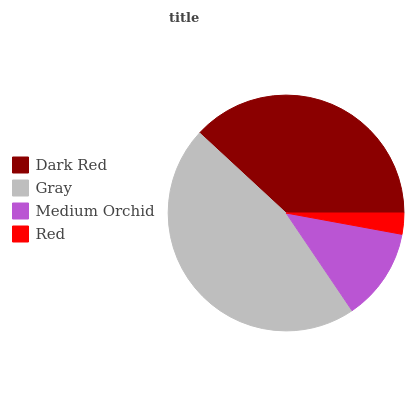Is Red the minimum?
Answer yes or no. Yes. Is Gray the maximum?
Answer yes or no. Yes. Is Medium Orchid the minimum?
Answer yes or no. No. Is Medium Orchid the maximum?
Answer yes or no. No. Is Gray greater than Medium Orchid?
Answer yes or no. Yes. Is Medium Orchid less than Gray?
Answer yes or no. Yes. Is Medium Orchid greater than Gray?
Answer yes or no. No. Is Gray less than Medium Orchid?
Answer yes or no. No. Is Dark Red the high median?
Answer yes or no. Yes. Is Medium Orchid the low median?
Answer yes or no. Yes. Is Red the high median?
Answer yes or no. No. Is Dark Red the low median?
Answer yes or no. No. 